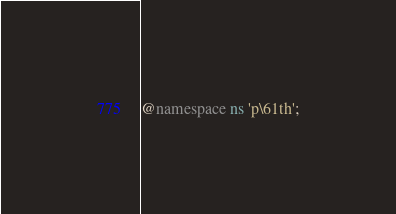Convert code to text. <code><loc_0><loc_0><loc_500><loc_500><_CSS_>@namespace ns 'p\61th';</code> 